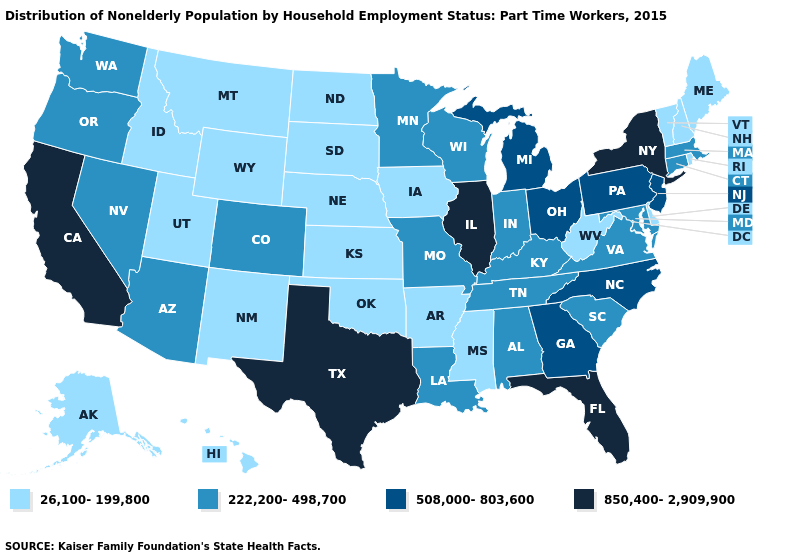Name the states that have a value in the range 850,400-2,909,900?
Concise answer only. California, Florida, Illinois, New York, Texas. Among the states that border Alabama , which have the highest value?
Short answer required. Florida. What is the highest value in the Northeast ?
Be succinct. 850,400-2,909,900. Name the states that have a value in the range 508,000-803,600?
Short answer required. Georgia, Michigan, New Jersey, North Carolina, Ohio, Pennsylvania. How many symbols are there in the legend?
Keep it brief. 4. How many symbols are there in the legend?
Concise answer only. 4. Name the states that have a value in the range 26,100-199,800?
Write a very short answer. Alaska, Arkansas, Delaware, Hawaii, Idaho, Iowa, Kansas, Maine, Mississippi, Montana, Nebraska, New Hampshire, New Mexico, North Dakota, Oklahoma, Rhode Island, South Dakota, Utah, Vermont, West Virginia, Wyoming. How many symbols are there in the legend?
Write a very short answer. 4. Which states hav the highest value in the Northeast?
Keep it brief. New York. Does the first symbol in the legend represent the smallest category?
Concise answer only. Yes. Does Delaware have a lower value than Pennsylvania?
Concise answer only. Yes. What is the value of Alabama?
Be succinct. 222,200-498,700. Does Nevada have a higher value than Tennessee?
Keep it brief. No. Which states have the lowest value in the USA?
Be succinct. Alaska, Arkansas, Delaware, Hawaii, Idaho, Iowa, Kansas, Maine, Mississippi, Montana, Nebraska, New Hampshire, New Mexico, North Dakota, Oklahoma, Rhode Island, South Dakota, Utah, Vermont, West Virginia, Wyoming. Among the states that border South Dakota , which have the highest value?
Concise answer only. Minnesota. 